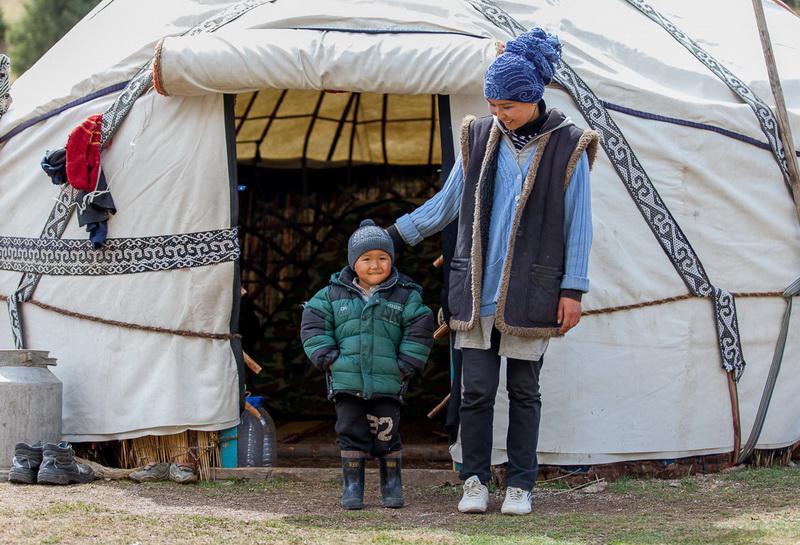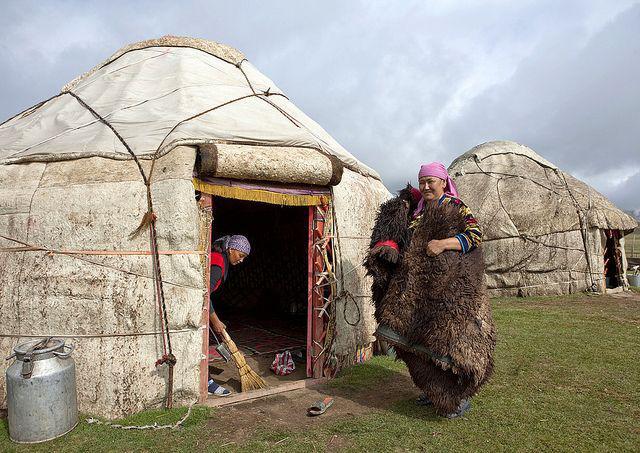The first image is the image on the left, the second image is the image on the right. Considering the images on both sides, is "A single white yurt is photographed with its door facing directly toward the camera, and at least one person stands outside the doorway." valid? Answer yes or no. Yes. The first image is the image on the left, the second image is the image on the right. Considering the images on both sides, is "At least one person is standing outside the hut in the image on the left." valid? Answer yes or no. Yes. The first image is the image on the left, the second image is the image on the right. Evaluate the accuracy of this statement regarding the images: "The building has a wooden ornamental door". Is it true? Answer yes or no. No. 